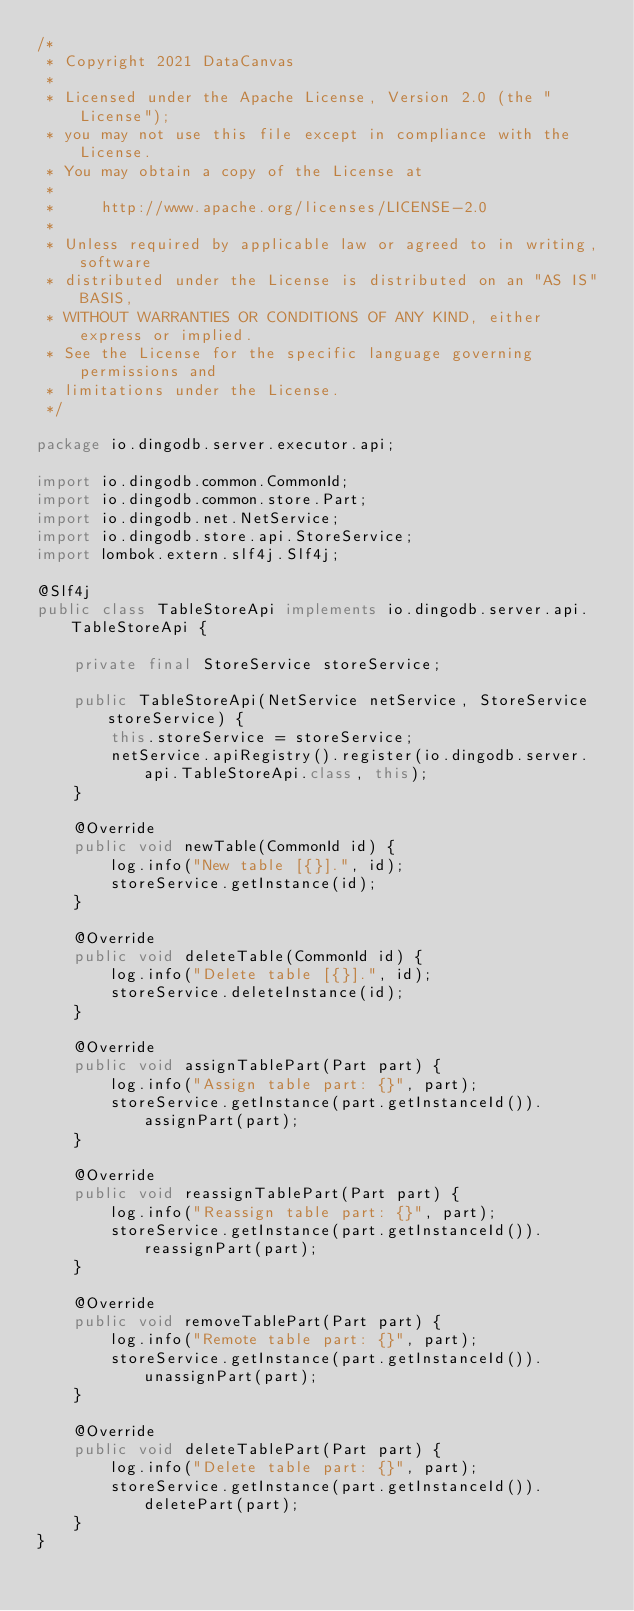<code> <loc_0><loc_0><loc_500><loc_500><_Java_>/*
 * Copyright 2021 DataCanvas
 *
 * Licensed under the Apache License, Version 2.0 (the "License");
 * you may not use this file except in compliance with the License.
 * You may obtain a copy of the License at
 *
 *     http://www.apache.org/licenses/LICENSE-2.0
 *
 * Unless required by applicable law or agreed to in writing, software
 * distributed under the License is distributed on an "AS IS" BASIS,
 * WITHOUT WARRANTIES OR CONDITIONS OF ANY KIND, either express or implied.
 * See the License for the specific language governing permissions and
 * limitations under the License.
 */

package io.dingodb.server.executor.api;

import io.dingodb.common.CommonId;
import io.dingodb.common.store.Part;
import io.dingodb.net.NetService;
import io.dingodb.store.api.StoreService;
import lombok.extern.slf4j.Slf4j;

@Slf4j
public class TableStoreApi implements io.dingodb.server.api.TableStoreApi {

    private final StoreService storeService;

    public TableStoreApi(NetService netService, StoreService storeService) {
        this.storeService = storeService;
        netService.apiRegistry().register(io.dingodb.server.api.TableStoreApi.class, this);
    }

    @Override
    public void newTable(CommonId id) {
        log.info("New table [{}].", id);
        storeService.getInstance(id);
    }

    @Override
    public void deleteTable(CommonId id) {
        log.info("Delete table [{}].", id);
        storeService.deleteInstance(id);
    }

    @Override
    public void assignTablePart(Part part) {
        log.info("Assign table part: {}", part);
        storeService.getInstance(part.getInstanceId()).assignPart(part);
    }

    @Override
    public void reassignTablePart(Part part) {
        log.info("Reassign table part: {}", part);
        storeService.getInstance(part.getInstanceId()).reassignPart(part);
    }

    @Override
    public void removeTablePart(Part part) {
        log.info("Remote table part: {}", part);
        storeService.getInstance(part.getInstanceId()).unassignPart(part);
    }

    @Override
    public void deleteTablePart(Part part) {
        log.info("Delete table part: {}", part);
        storeService.getInstance(part.getInstanceId()).deletePart(part);
    }
}
</code> 